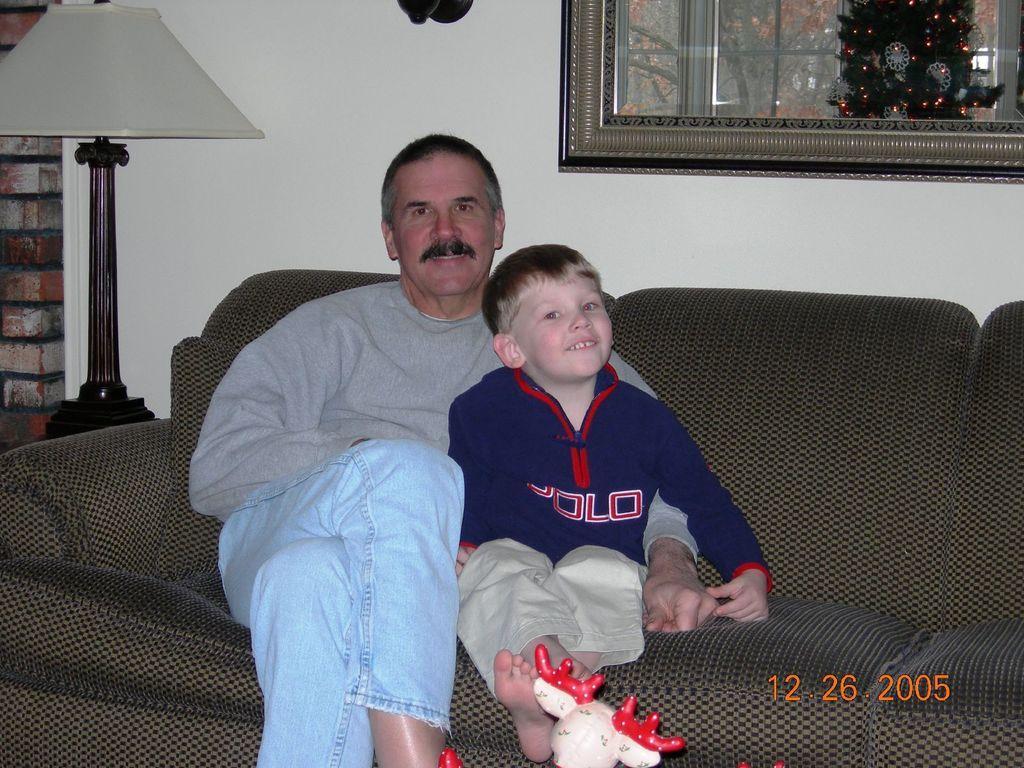Can you describe this image briefly? In this image, I can see two persons sitting on a couch and smiling. On the left side of the image, there is a lamp. In the background, I can see a photo frame attached to the wall. At the bottom of the image, I can see a toy and there is a watermark. 